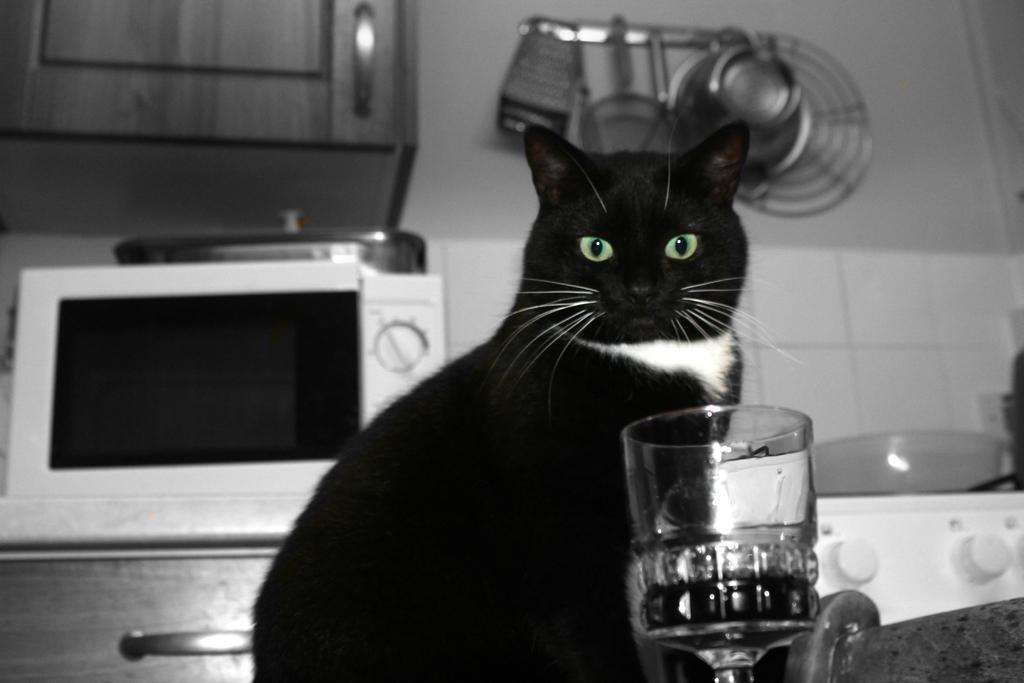Can you describe this image briefly? In this picture we can see a black color cat is sitting, there is a glass in the front, on the left side there is an oven, on the right side we can see a stove and a bowl, there is a cupboard at the left top of the picture, we can see a wall, a pan, a plate and some things present in the background. 